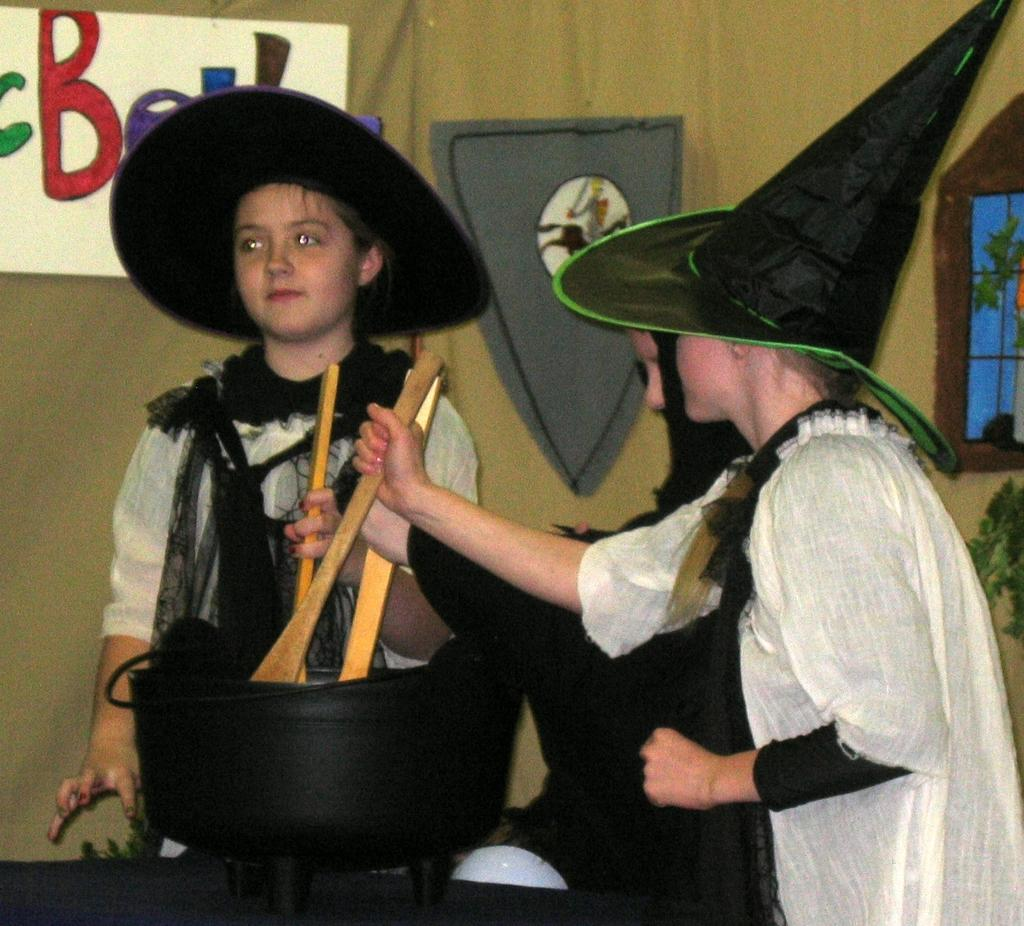Who is present in the image? There are children in the image. What are the children doing in the image? The children are standing. What are the children wearing on their heads? The children are wearing black hats. What are the children holding in their hands? The children are holding objects in their hands. What can be seen on the wall in the background of the image? There are objects attached to the wall in the background of the image. What color is the blood on the children's shoes in the image? There is no blood or shoes present in the image; the children are wearing black hats and holding objects. What type of paint is being used by the children in the image? There is no paint or painting activity depicted in the image; the children are standing and holding objects. 